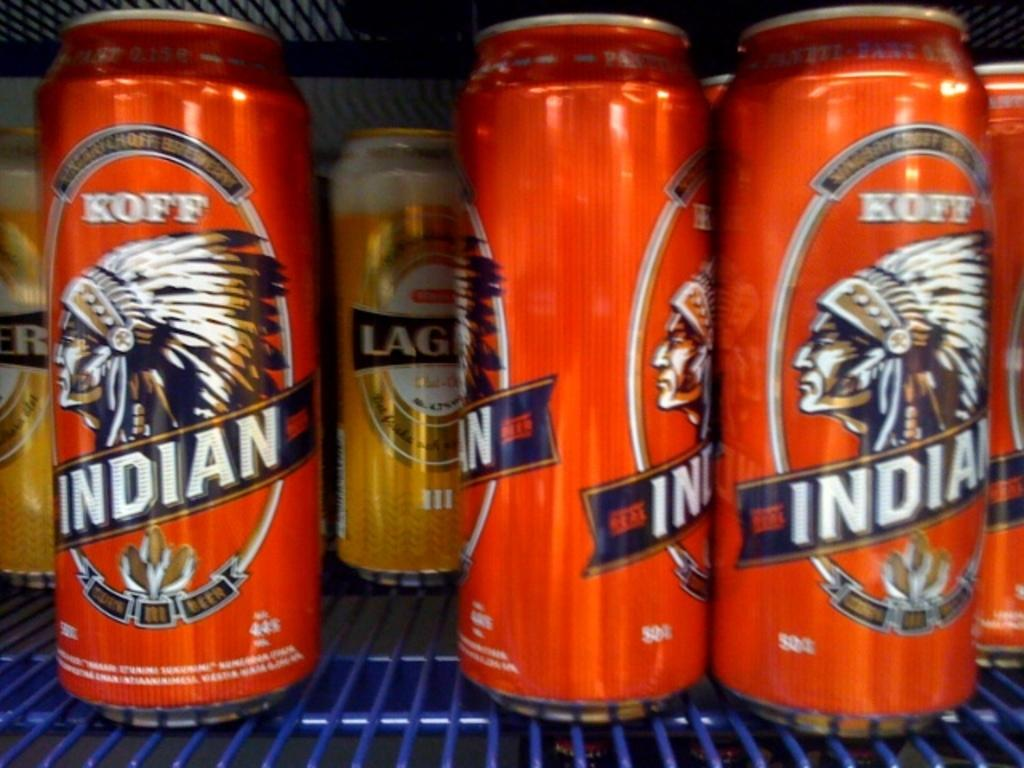<image>
Give a short and clear explanation of the subsequent image. Several orange cans of Koff indian beer sitting on a blue shelf 